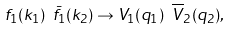<formula> <loc_0><loc_0><loc_500><loc_500>f _ { 1 } ( k _ { 1 } ) \ \bar { f } _ { 1 } ( k _ { 2 } ) \to V _ { 1 } ( q _ { 1 } ) \ \overline { V } _ { 2 } ( q _ { 2 } ) ,</formula> 